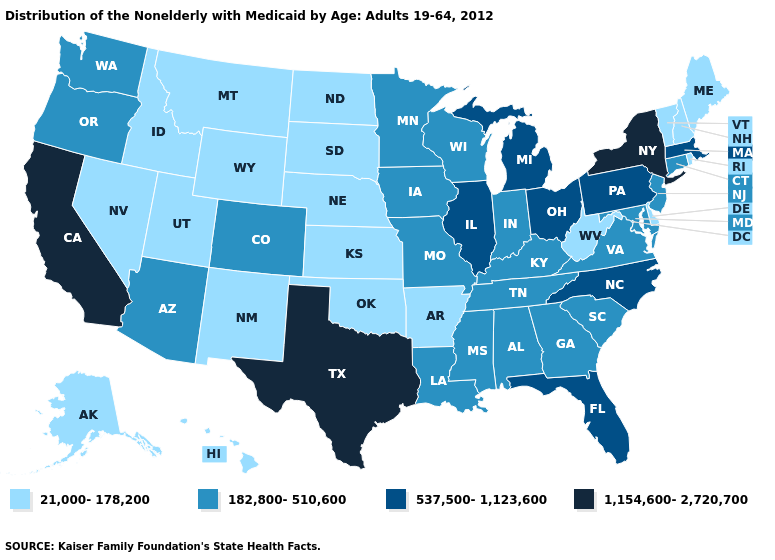Does Texas have the same value as Arkansas?
Quick response, please. No. Is the legend a continuous bar?
Concise answer only. No. Name the states that have a value in the range 21,000-178,200?
Be succinct. Alaska, Arkansas, Delaware, Hawaii, Idaho, Kansas, Maine, Montana, Nebraska, Nevada, New Hampshire, New Mexico, North Dakota, Oklahoma, Rhode Island, South Dakota, Utah, Vermont, West Virginia, Wyoming. Which states hav the highest value in the Northeast?
Concise answer only. New York. Which states have the lowest value in the USA?
Short answer required. Alaska, Arkansas, Delaware, Hawaii, Idaho, Kansas, Maine, Montana, Nebraska, Nevada, New Hampshire, New Mexico, North Dakota, Oklahoma, Rhode Island, South Dakota, Utah, Vermont, West Virginia, Wyoming. What is the highest value in the South ?
Write a very short answer. 1,154,600-2,720,700. Does the first symbol in the legend represent the smallest category?
Answer briefly. Yes. Which states have the lowest value in the USA?
Be succinct. Alaska, Arkansas, Delaware, Hawaii, Idaho, Kansas, Maine, Montana, Nebraska, Nevada, New Hampshire, New Mexico, North Dakota, Oklahoma, Rhode Island, South Dakota, Utah, Vermont, West Virginia, Wyoming. Among the states that border New York , does Vermont have the lowest value?
Quick response, please. Yes. What is the highest value in the USA?
Be succinct. 1,154,600-2,720,700. Name the states that have a value in the range 182,800-510,600?
Give a very brief answer. Alabama, Arizona, Colorado, Connecticut, Georgia, Indiana, Iowa, Kentucky, Louisiana, Maryland, Minnesota, Mississippi, Missouri, New Jersey, Oregon, South Carolina, Tennessee, Virginia, Washington, Wisconsin. Does Alaska have a higher value than Oregon?
Write a very short answer. No. Does the first symbol in the legend represent the smallest category?
Concise answer only. Yes. Does North Carolina have the highest value in the USA?
Write a very short answer. No. Name the states that have a value in the range 182,800-510,600?
Be succinct. Alabama, Arizona, Colorado, Connecticut, Georgia, Indiana, Iowa, Kentucky, Louisiana, Maryland, Minnesota, Mississippi, Missouri, New Jersey, Oregon, South Carolina, Tennessee, Virginia, Washington, Wisconsin. 